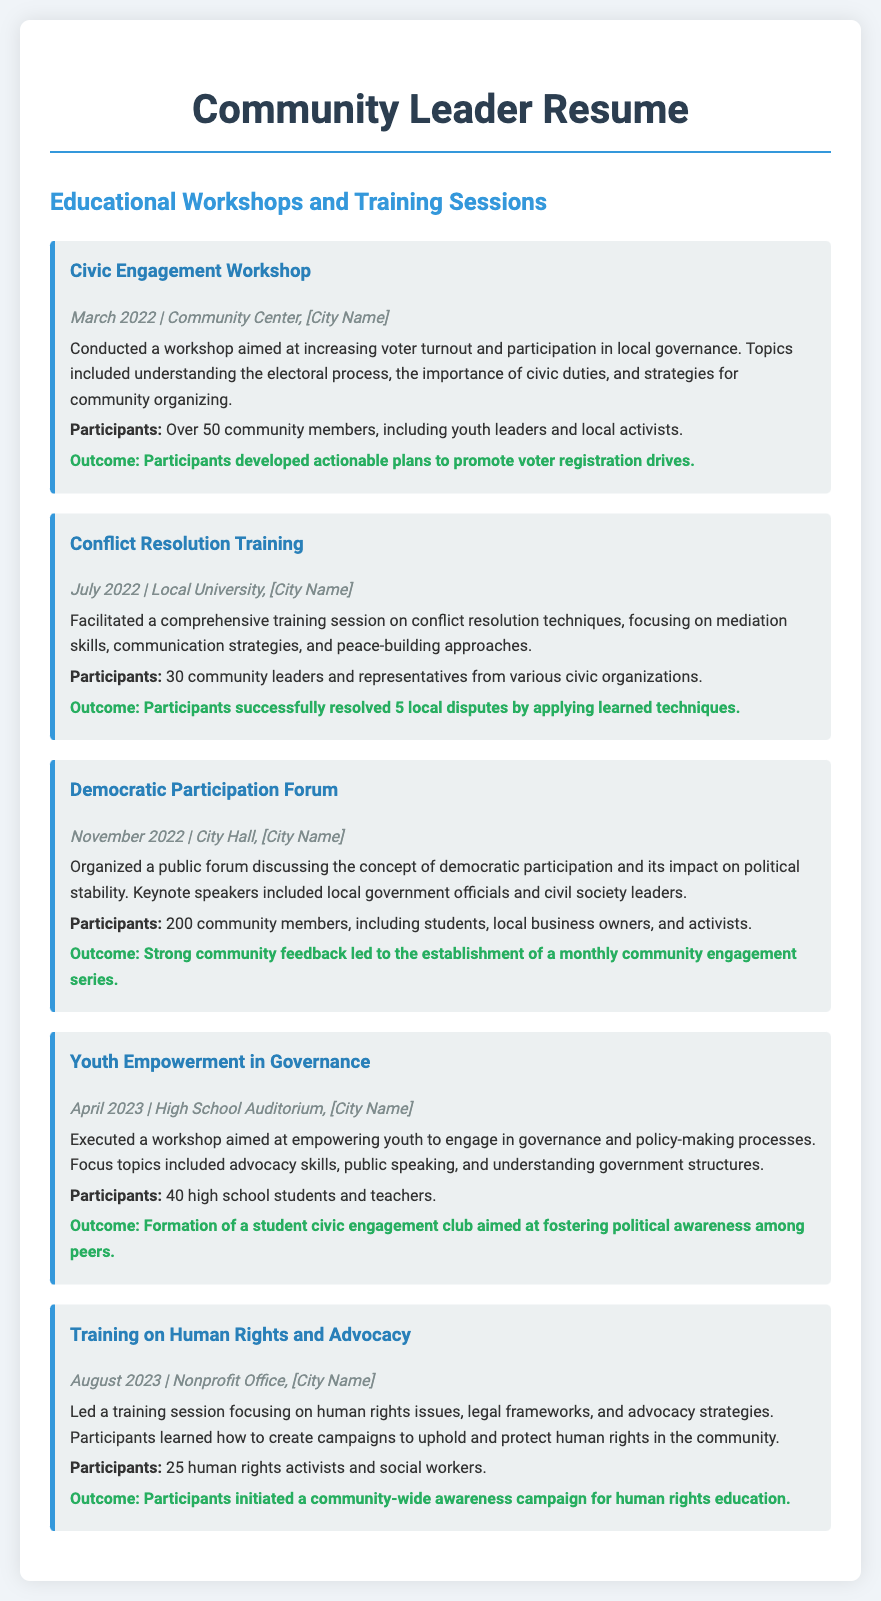What was the date of the Civic Engagement Workshop? The date of the Civic Engagement Workshop is listed in the document as March 2022.
Answer: March 2022 How many participants attended the Conflict Resolution Training? The document states that 30 community leaders and representatives attended the Conflict Resolution Training.
Answer: 30 What was the outcome of the Democratic Participation Forum? The outcome listed in the document for the Democratic Participation Forum is the establishment of a monthly community engagement series.
Answer: Establishment of a monthly community engagement series Where was the Youth Empowerment in Governance workshop held? The location of the Youth Empowerment in Governance workshop is mentioned as High School Auditorium, [City Name].
Answer: High School Auditorium, [City Name] What was the main focus of the Training on Human Rights and Advocacy? The document highlights that the main focus of the Training on Human Rights and Advocacy was on human rights issues, legal frameworks, and advocacy strategies.
Answer: Human rights issues, legal frameworks, and advocacy strategies Why was the Civic Engagement Workshop conducted? The workshop aimed at increasing voter turnout and participation in local governance according to the document.
Answer: Increasing voter turnout and participation in local governance Who were the keynote speakers at the Democratic Participation Forum? The document mentions that the keynote speakers included local government officials and civil society leaders.
Answer: Local government officials and civil society leaders What action did participants take after the Youth Empowerment in Governance workshop? The participants formed a student civic engagement club according to the document.
Answer: Formation of a student civic engagement club 